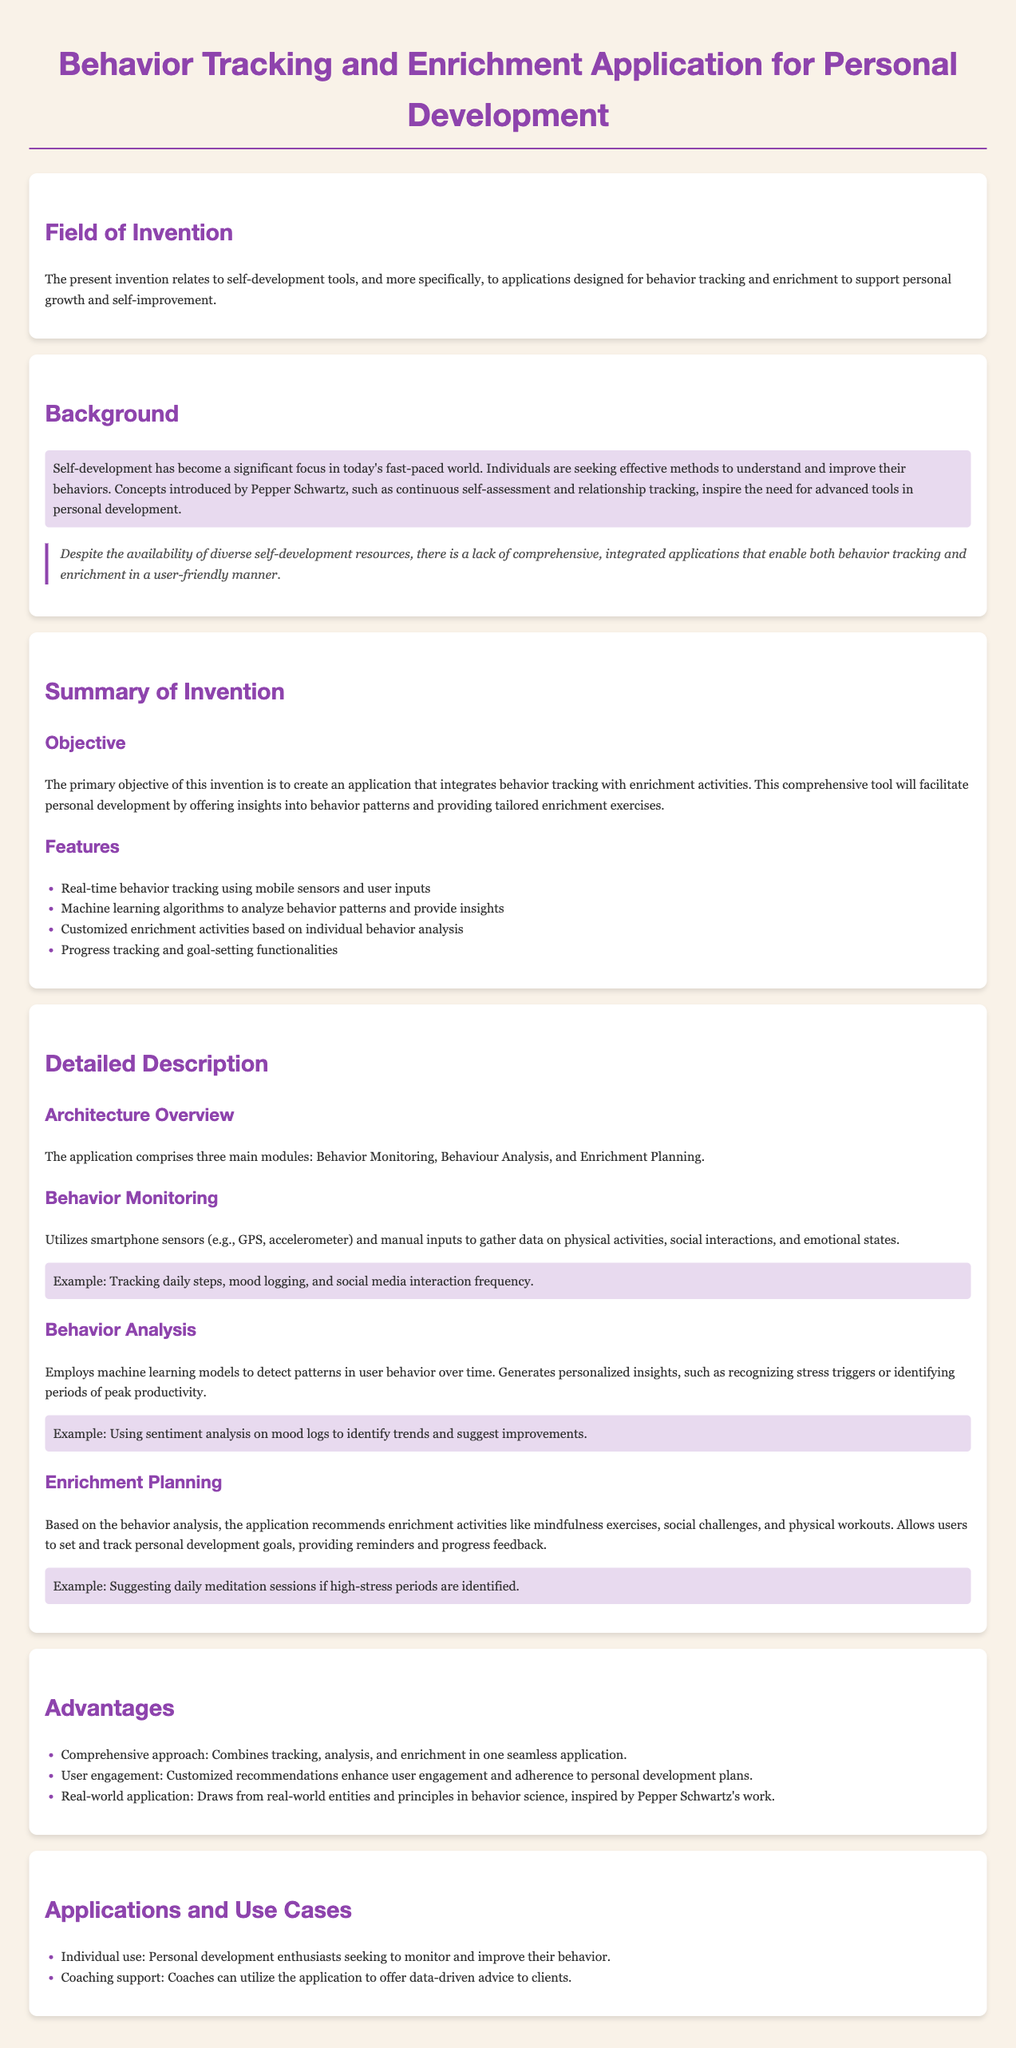What is the title of the patent application? The title of the patent application is presented at the beginning of the document, stating the specific focus of the invention.
Answer: Behavior Tracking and Enrichment Application for Personal Development What are the main modules of the application? The document outlines three main modules that comprise the application's architecture: Behavior Monitoring, Behavior Analysis, and Enrichment Planning.
Answer: Behavior Monitoring, Behavior Analysis, Enrichment Planning Which concepts inspire the need for this application? The background section mentions concepts introduced by a specific author, which inspired the creation of the application.
Answer: Continuous self-assessment and relationship tracking What is the primary objective of this invention? The objective is clearly stated in the summary section, focusing on what the application aims to achieve in personal development.
Answer: To integrate behavior tracking with enrichment activities What technology is used for behavior tracking? The document specifies the type of technology incorporated into the application for gathering user data in the Monitoring module.
Answer: Mobile sensors and user inputs How does the application provide customized enrichment activities? The mechanism for delivering tailored activities is detailed in the summary, indicating its basis on the analysis of user behavior.
Answer: Customized based on individual behavior analysis What is one advantage of this application? The advantages section lists several benefits, highlighting a key aspect of the application's design and user experience.
Answer: Comprehensive approach Who can benefit from this application? The applications and use cases section identifies potential users that the invention is designed for, outlining its relevance and target audience.
Answer: Individual use and coaching support 